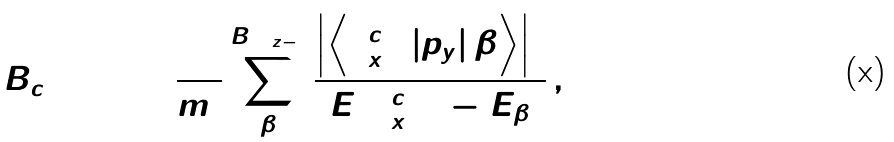<formula> <loc_0><loc_0><loc_500><loc_500>B _ { c 2 } = 1 + \frac { 2 } { m _ { 0 } } \sum _ { \beta } ^ { B \left [ \Gamma _ { z - } \right ] } \frac { \left | \left \langle \Gamma _ { x + } ^ { c 2 } \left | p _ { y } \right | \beta \right \rangle \right | ^ { 2 } } { E ( \Gamma _ { x + } ^ { c 2 } ) - E _ { \beta } } \, ,</formula> 